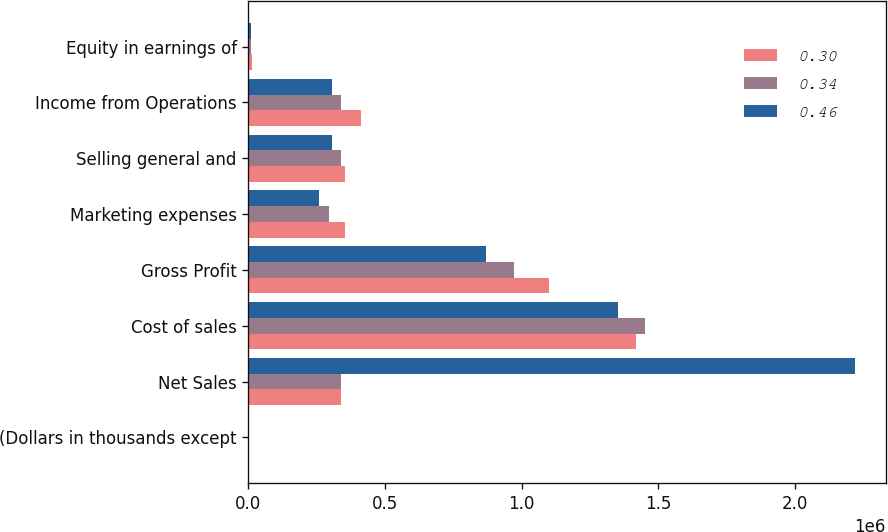Convert chart to OTSL. <chart><loc_0><loc_0><loc_500><loc_500><stacked_bar_chart><ecel><fcel>(Dollars in thousands except<fcel>Net Sales<fcel>Cost of sales<fcel>Gross Profit<fcel>Marketing expenses<fcel>Selling general and<fcel>Income from Operations<fcel>Equity in earnings of<nl><fcel>0.3<fcel>2009<fcel>338794<fcel>1.41993e+06<fcel>1.10099e+06<fcel>353588<fcel>354510<fcel>412892<fcel>12050<nl><fcel>0.34<fcel>2008<fcel>338794<fcel>1.45068e+06<fcel>971718<fcel>294130<fcel>337256<fcel>340332<fcel>11334<nl><fcel>0.46<fcel>2007<fcel>2.22094e+06<fcel>1.35304e+06<fcel>867898<fcel>256743<fcel>306121<fcel>305034<fcel>8236<nl></chart> 